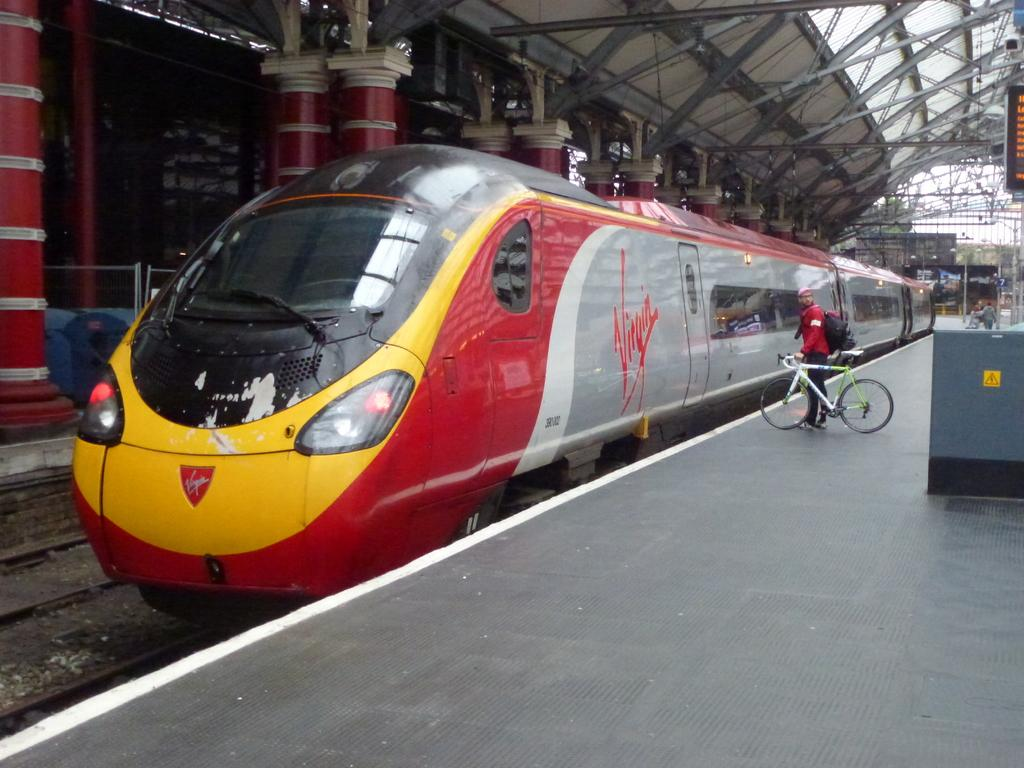Provide a one-sentence caption for the provided image. A train sits at the station with the word Virgin written on the side. 